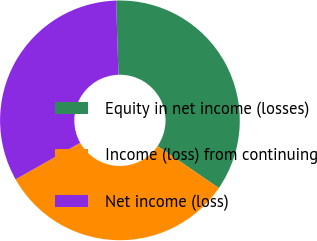<chart> <loc_0><loc_0><loc_500><loc_500><pie_chart><fcel>Equity in net income (losses)<fcel>Income (loss) from continuing<fcel>Net income (loss)<nl><fcel>35.06%<fcel>32.25%<fcel>32.68%<nl></chart> 